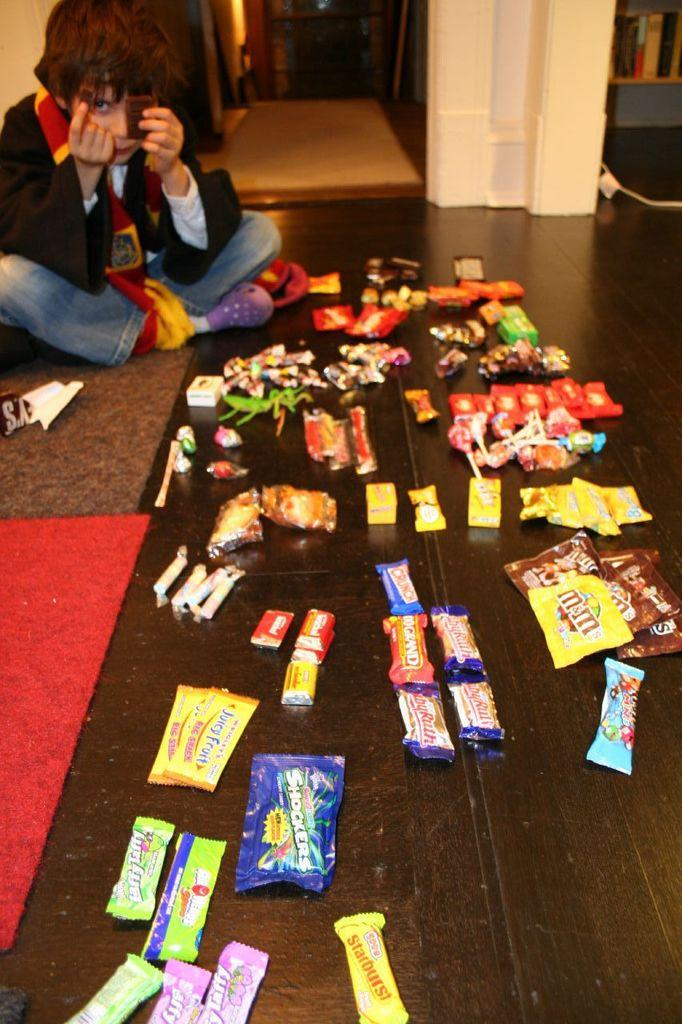What is placed on the floor in the image? There are many chocolates placed on the floor in the image. Where is the child located in the image? The child is sitting on the left side of the image. What can be seen in the background of the image? There are objects visible in the background of the image. What type of baseball is the child playing with in the image? There is no baseball present in the image; the child is sitting on the left side of the image. 